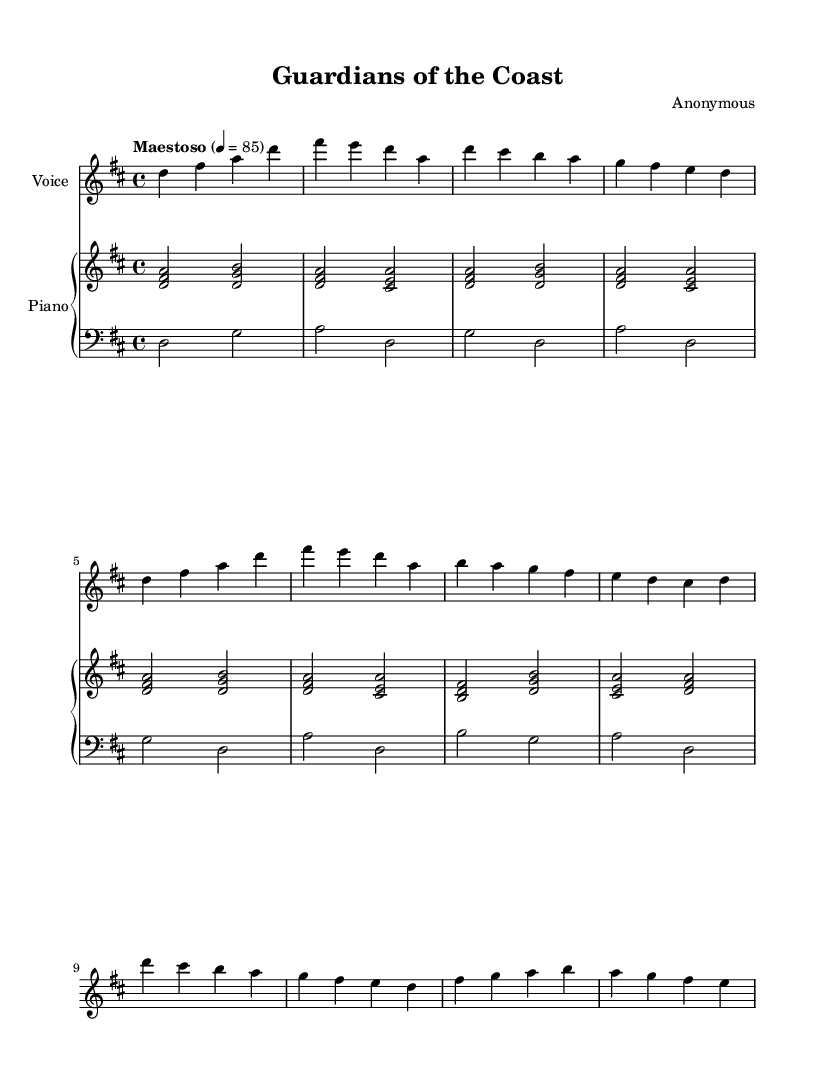What is the key signature of this music? The key signature is determined by the sharp or flat symbols at the beginning of the staff. In this case, there are two sharps (F# and C#), indicating it is in D major.
Answer: D major What is the time signature of this music? The time signature is found at the beginning of the music and shows how many beats are in each measure. Here, it shows a 4 over 4, meaning there are four beats in each measure, commonly called "common time."
Answer: 4/4 What is the tempo marking for this piece? The tempo marking indicates how fast the music should be played, which is found near the top of the music. This piece is marked "Maestoso" with a metronome setting of 85 beats per minute.
Answer: Maestoso 4 = 85 What section follows the introduction in this opera? The structure of the music denotes sections, where the introduction is followed by a verse. The question can be answered by examining the layout of the lyrics and music. The verse lyrics are present right after the introduction section, indicating what follows.
Answer: Verse How many lines are in the chorus? The chorus lyrics can be counted directly from the sheet music, where the chorus section is presented. There are four lines of lyrics listed under the chorus, which makes it easy to determine.
Answer: Four In which voice part is the primary melody found? The primary melody is usually indicated by the higher staff in the sheet music and is typically sung by the soprano in opera. In this case, the soprano part carries the main melody.
Answer: Soprano What emotional theme does the chorus convey? By analyzing the lyrics in the chorus section, which speak of admiration for the guardians and the protective role of naval forces, the emotional theme can be derived from the imagery and message expressed in the text. The chorus conveys themes of admiration and inspiration.
Answer: Admiration and inspiration 